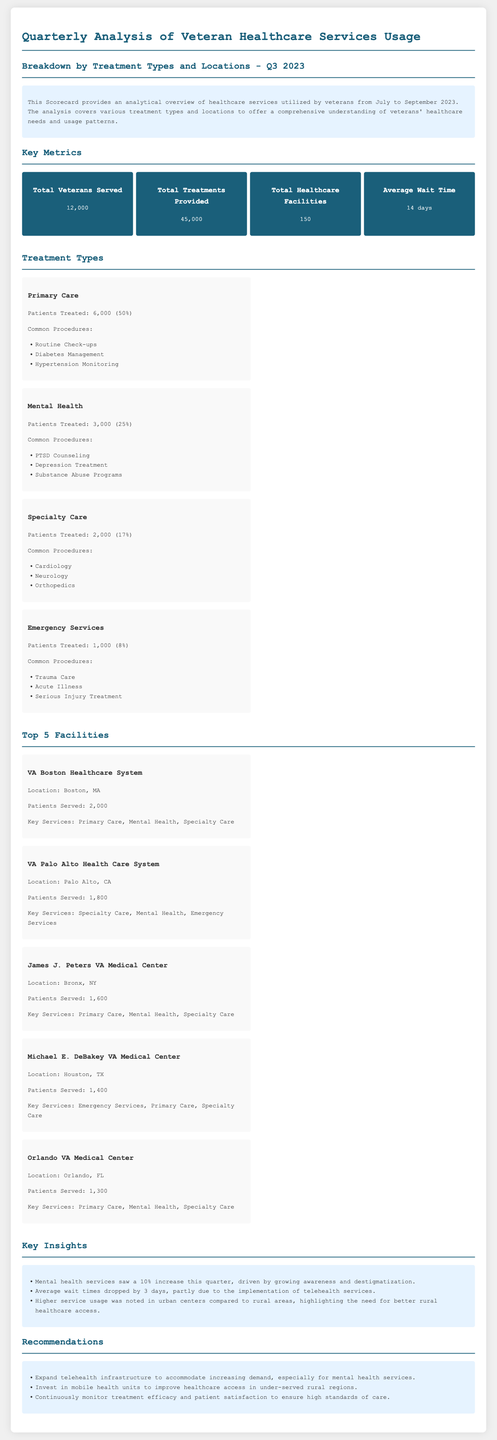What is the total number of veterans served? The total number of veterans served is stated in the document, which is 12,000.
Answer: 12,000 What is the percentage of patients treated in Primary Care? The document specifies that 6,000 patients were treated in Primary Care, which is 50% of the total 12,000 veterans served.
Answer: 50% How many total treatments were provided? The total treatments provided are mentioned as 45,000 in the metrics section of the document.
Answer: 45,000 What was the average wait time for treatments? The metric section provides the average wait time for treatments as 14 days.
Answer: 14 days Which facility served the most patients? The document lists the VA Boston Healthcare System as the facility that served the most patients, with 2,000 served.
Answer: VA Boston Healthcare System What type of care had a 10% increase in service usage? The insights section indicates that mental health services saw a 10% increase this quarter.
Answer: Mental health What recommendations were made to improve healthcare access? The recommendations section advises to invest in mobile health units to improve access.
Answer: Invest in mobile health units How many healthcare facilities are mentioned in the metrics? The document states that there are 150 total healthcare facilities listed under the key metrics.
Answer: 150 What was noted about healthcare usage in urban versus rural areas? Insights mention that higher service usage was noted in urban centers compared to rural areas.
Answer: Urban centers 